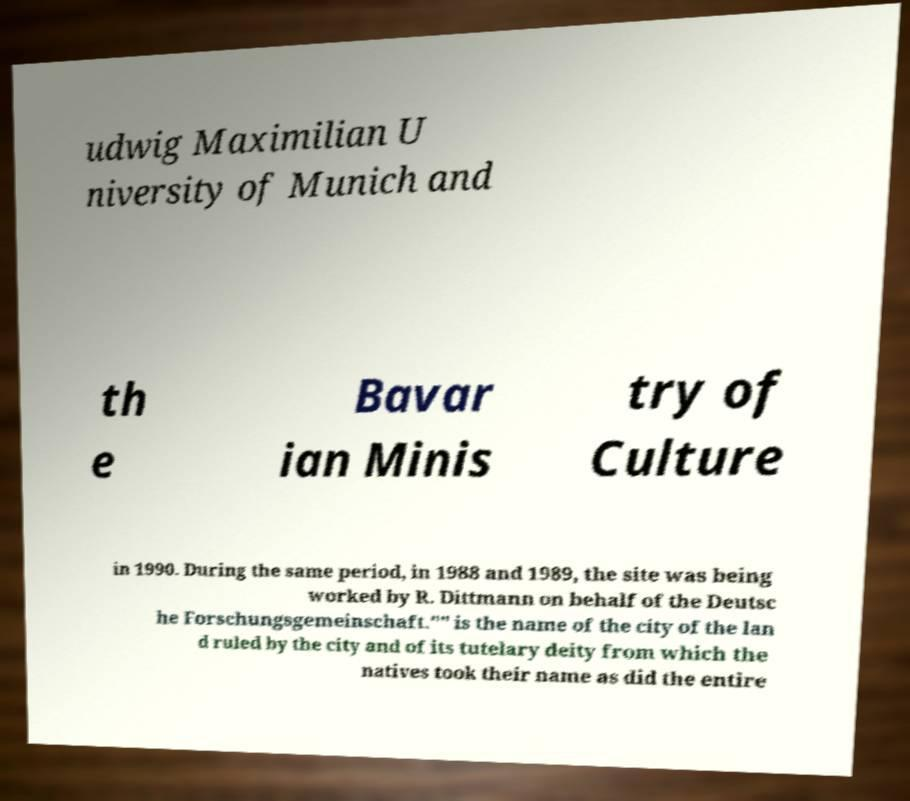For documentation purposes, I need the text within this image transcribed. Could you provide that? udwig Maximilian U niversity of Munich and th e Bavar ian Minis try of Culture in 1990. During the same period, in 1988 and 1989, the site was being worked by R. Dittmann on behalf of the Deutsc he Forschungsgemeinschaft."" is the name of the city of the lan d ruled by the city and of its tutelary deity from which the natives took their name as did the entire 